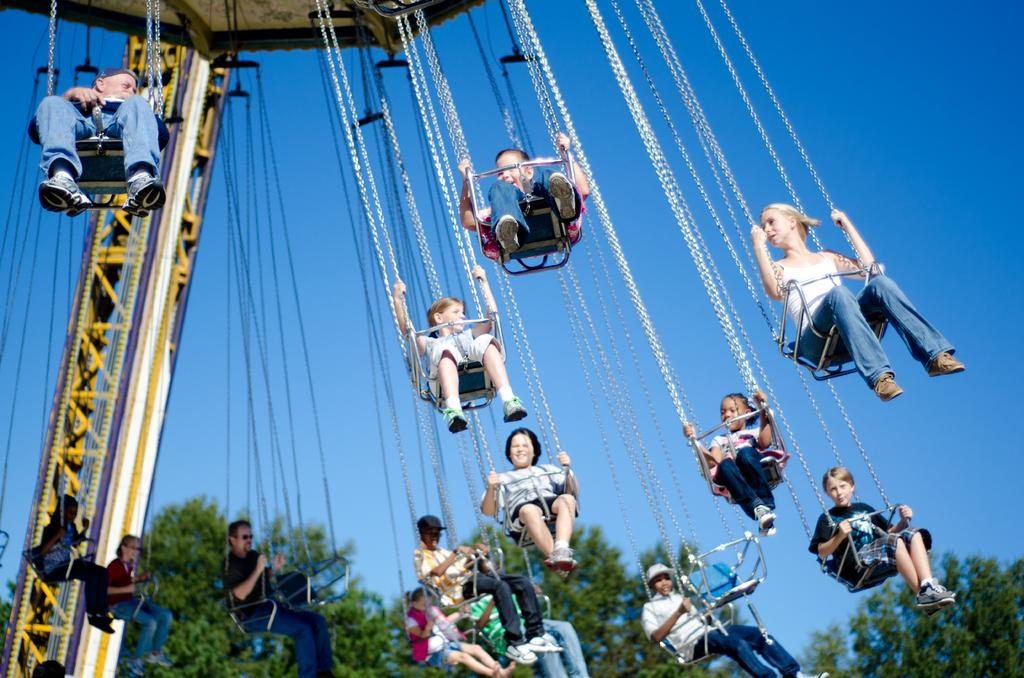What are the people in the image doing? The people in the image are on a chain swing ride. What can be seen in the background of the image? The sky and trees are visible in the background of the image. How many yams are being tested in the image? There are no yams or testing activities present in the image. 